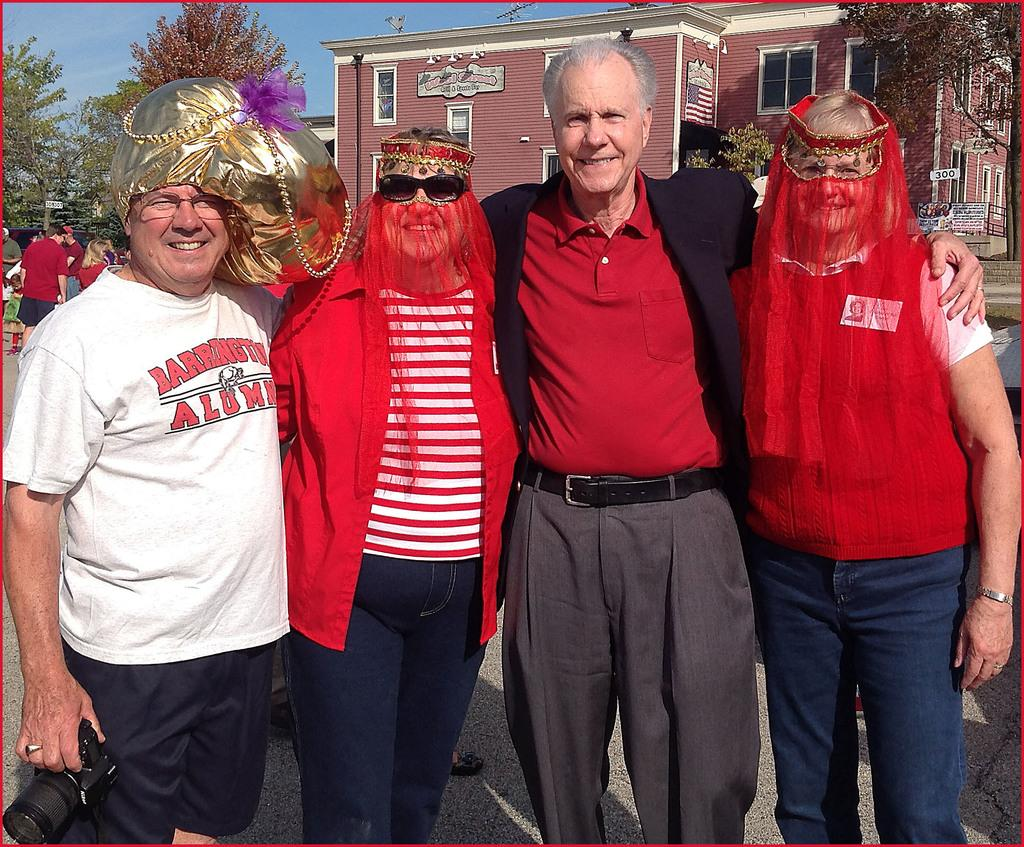How many people are in the image? There is a group of people in the image, but the exact number is not specified. Where are the people located in the image? The people are standing on the ground in the image. What can be seen in the background of the image? There are buildings, trees, and the sky visible in the background of the image. Can you describe any other objects in the background of the image? There are other unspecified objects in the background of the image. What type of stick is being used by the hospital in the image? There is no hospital or stick present in the image. 